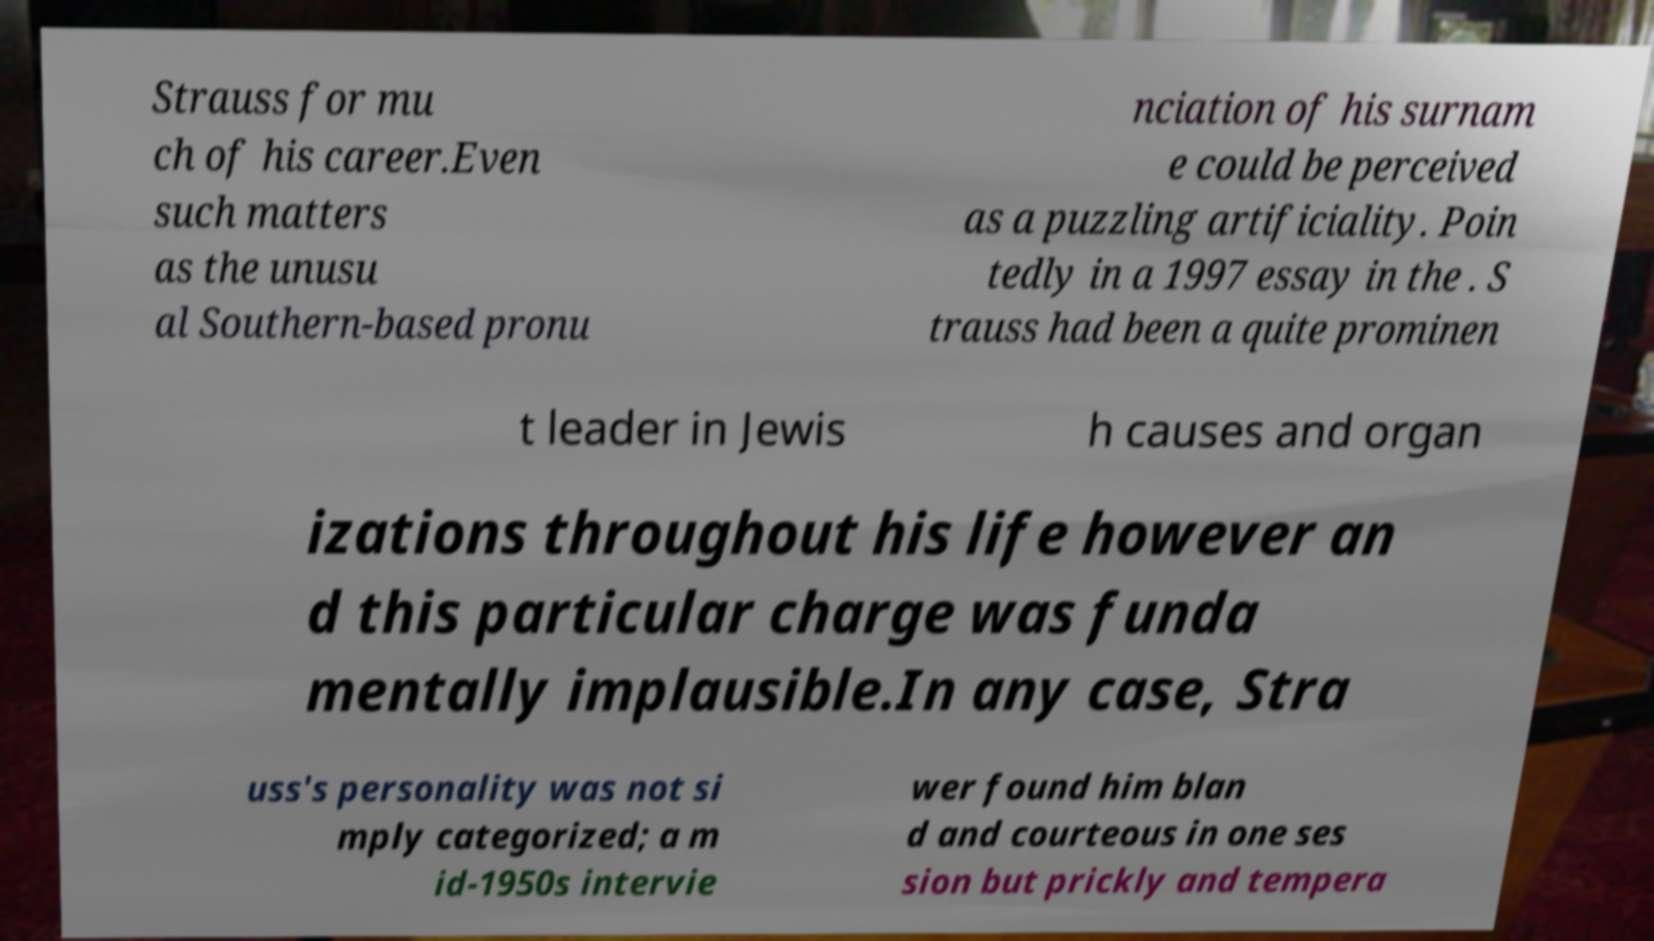Please read and relay the text visible in this image. What does it say? Strauss for mu ch of his career.Even such matters as the unusu al Southern-based pronu nciation of his surnam e could be perceived as a puzzling artificiality. Poin tedly in a 1997 essay in the . S trauss had been a quite prominen t leader in Jewis h causes and organ izations throughout his life however an d this particular charge was funda mentally implausible.In any case, Stra uss's personality was not si mply categorized; a m id-1950s intervie wer found him blan d and courteous in one ses sion but prickly and tempera 